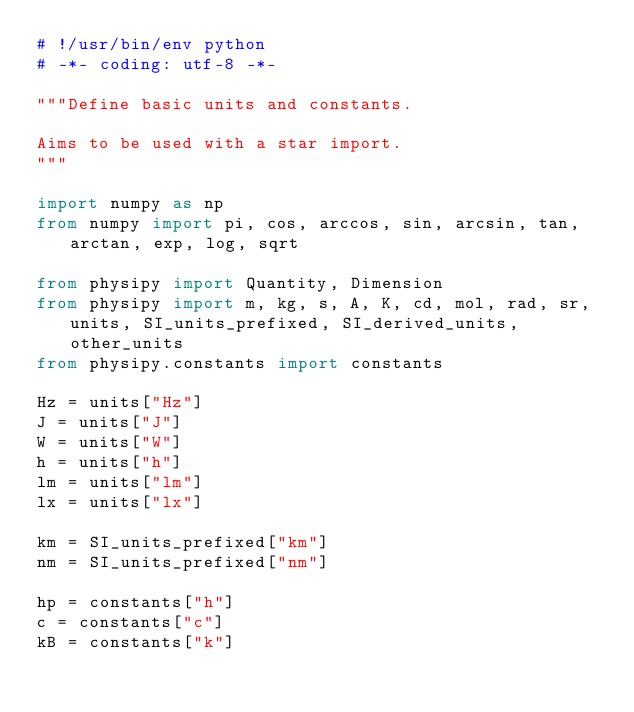Convert code to text. <code><loc_0><loc_0><loc_500><loc_500><_Python_># !/usr/bin/env python
# -*- coding: utf-8 -*-

"""Define basic units and constants.

Aims to be used with a star import.
"""

import numpy as np
from numpy import pi, cos, arccos, sin, arcsin, tan, arctan, exp, log, sqrt

from physipy import Quantity, Dimension
from physipy import m, kg, s, A, K, cd, mol, rad, sr, units, SI_units_prefixed, SI_derived_units, other_units
from physipy.constants import constants

Hz = units["Hz"]
J = units["J"]
W = units["W"]
h = units["h"]
lm = units["lm"]
lx = units["lx"]

km = SI_units_prefixed["km"]
nm = SI_units_prefixed["nm"]

hp = constants["h"]
c = constants["c"]
kB = constants["k"]</code> 